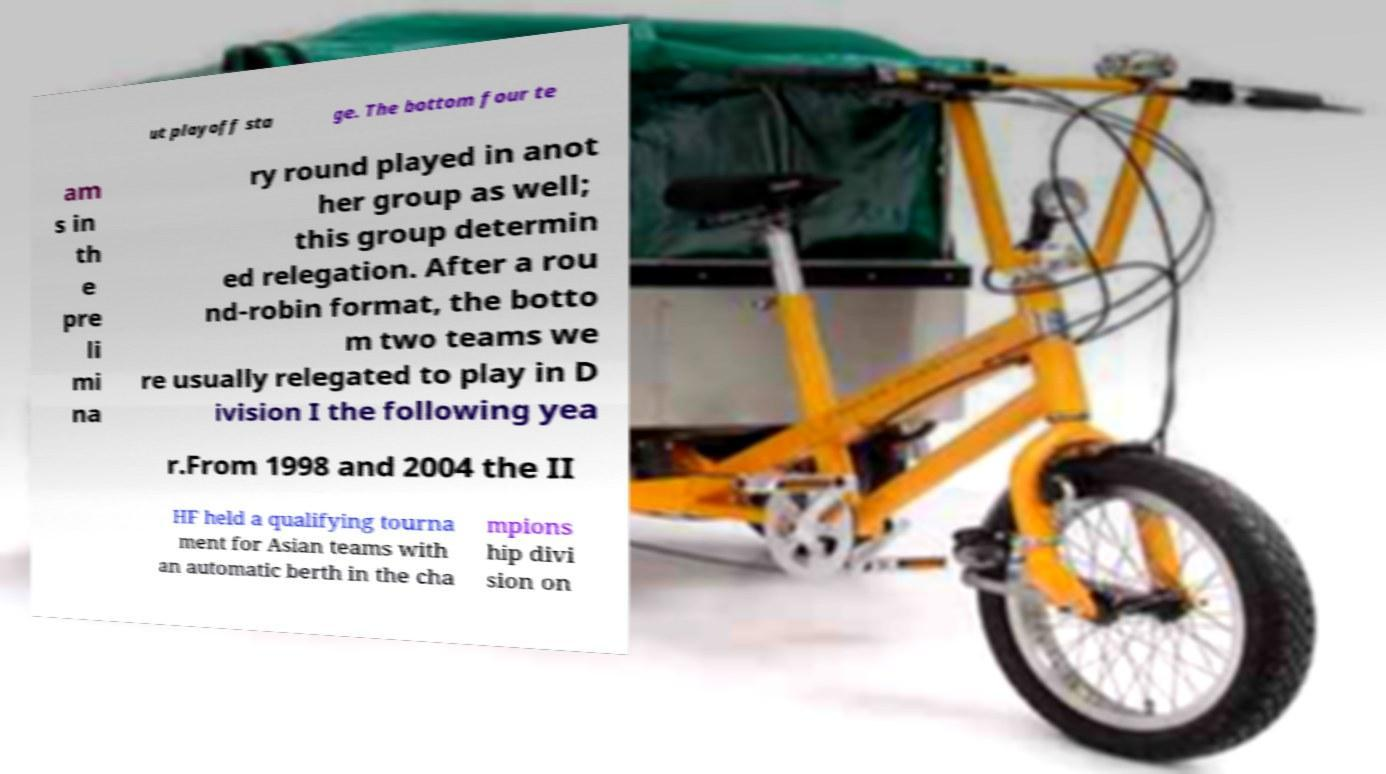For documentation purposes, I need the text within this image transcribed. Could you provide that? ut playoff sta ge. The bottom four te am s in th e pre li mi na ry round played in anot her group as well; this group determin ed relegation. After a rou nd-robin format, the botto m two teams we re usually relegated to play in D ivision I the following yea r.From 1998 and 2004 the II HF held a qualifying tourna ment for Asian teams with an automatic berth in the cha mpions hip divi sion on 